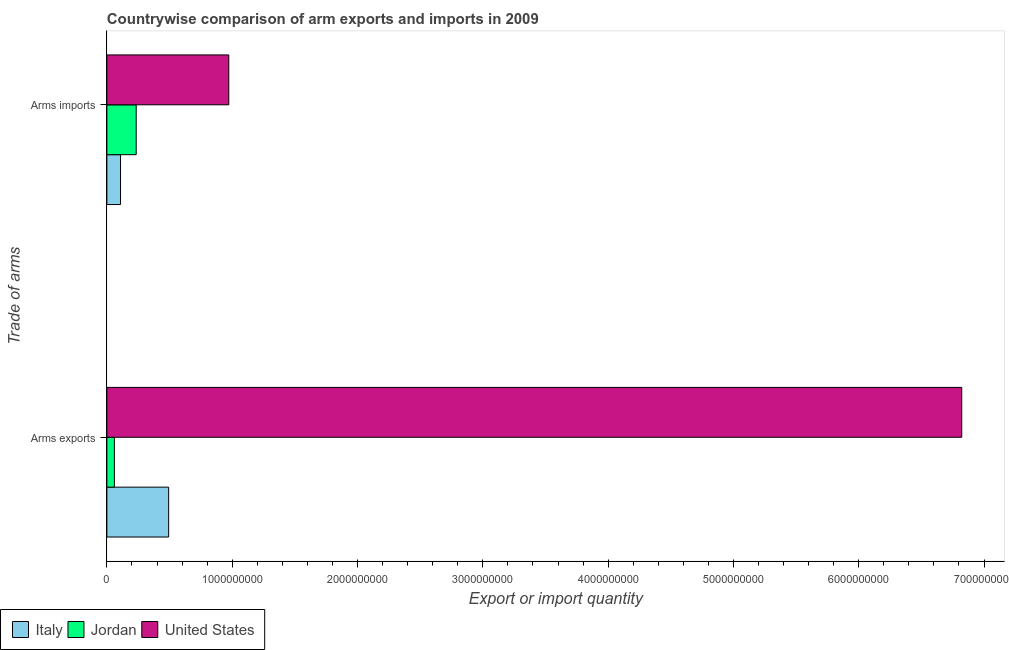How many different coloured bars are there?
Make the answer very short. 3. How many groups of bars are there?
Provide a short and direct response. 2. How many bars are there on the 2nd tick from the top?
Keep it short and to the point. 3. What is the label of the 1st group of bars from the top?
Offer a very short reply. Arms imports. What is the arms imports in Italy?
Offer a terse response. 1.09e+08. Across all countries, what is the maximum arms exports?
Keep it short and to the point. 6.82e+09. Across all countries, what is the minimum arms imports?
Provide a succinct answer. 1.09e+08. In which country was the arms exports maximum?
Keep it short and to the point. United States. In which country was the arms imports minimum?
Make the answer very short. Italy. What is the total arms imports in the graph?
Make the answer very short. 1.32e+09. What is the difference between the arms imports in Jordan and that in Italy?
Your answer should be very brief. 1.25e+08. What is the difference between the arms exports in United States and the arms imports in Jordan?
Your answer should be very brief. 6.59e+09. What is the average arms imports per country?
Offer a terse response. 4.39e+08. What is the difference between the arms imports and arms exports in Italy?
Your answer should be compact. -3.84e+08. What is the ratio of the arms exports in Italy to that in Jordan?
Provide a succinct answer. 8.22. Is the arms exports in United States less than that in Italy?
Keep it short and to the point. No. What does the 2nd bar from the top in Arms exports represents?
Ensure brevity in your answer.  Jordan. What does the 1st bar from the bottom in Arms exports represents?
Offer a terse response. Italy. How many bars are there?
Give a very brief answer. 6. Are all the bars in the graph horizontal?
Make the answer very short. Yes. What is the difference between two consecutive major ticks on the X-axis?
Provide a succinct answer. 1.00e+09. Does the graph contain any zero values?
Your answer should be very brief. No. Does the graph contain grids?
Your answer should be compact. No. What is the title of the graph?
Your response must be concise. Countrywise comparison of arm exports and imports in 2009. Does "Tanzania" appear as one of the legend labels in the graph?
Provide a short and direct response. No. What is the label or title of the X-axis?
Ensure brevity in your answer.  Export or import quantity. What is the label or title of the Y-axis?
Give a very brief answer. Trade of arms. What is the Export or import quantity of Italy in Arms exports?
Your answer should be compact. 4.93e+08. What is the Export or import quantity of Jordan in Arms exports?
Provide a succinct answer. 6.00e+07. What is the Export or import quantity in United States in Arms exports?
Provide a short and direct response. 6.82e+09. What is the Export or import quantity in Italy in Arms imports?
Offer a very short reply. 1.09e+08. What is the Export or import quantity of Jordan in Arms imports?
Ensure brevity in your answer.  2.34e+08. What is the Export or import quantity of United States in Arms imports?
Make the answer very short. 9.73e+08. Across all Trade of arms, what is the maximum Export or import quantity of Italy?
Your answer should be very brief. 4.93e+08. Across all Trade of arms, what is the maximum Export or import quantity of Jordan?
Provide a short and direct response. 2.34e+08. Across all Trade of arms, what is the maximum Export or import quantity of United States?
Your response must be concise. 6.82e+09. Across all Trade of arms, what is the minimum Export or import quantity of Italy?
Provide a short and direct response. 1.09e+08. Across all Trade of arms, what is the minimum Export or import quantity in Jordan?
Your answer should be compact. 6.00e+07. Across all Trade of arms, what is the minimum Export or import quantity in United States?
Offer a terse response. 9.73e+08. What is the total Export or import quantity in Italy in the graph?
Offer a very short reply. 6.02e+08. What is the total Export or import quantity in Jordan in the graph?
Provide a succinct answer. 2.94e+08. What is the total Export or import quantity in United States in the graph?
Keep it short and to the point. 7.80e+09. What is the difference between the Export or import quantity in Italy in Arms exports and that in Arms imports?
Ensure brevity in your answer.  3.84e+08. What is the difference between the Export or import quantity in Jordan in Arms exports and that in Arms imports?
Provide a succinct answer. -1.74e+08. What is the difference between the Export or import quantity of United States in Arms exports and that in Arms imports?
Offer a very short reply. 5.85e+09. What is the difference between the Export or import quantity of Italy in Arms exports and the Export or import quantity of Jordan in Arms imports?
Ensure brevity in your answer.  2.59e+08. What is the difference between the Export or import quantity in Italy in Arms exports and the Export or import quantity in United States in Arms imports?
Ensure brevity in your answer.  -4.80e+08. What is the difference between the Export or import quantity of Jordan in Arms exports and the Export or import quantity of United States in Arms imports?
Make the answer very short. -9.13e+08. What is the average Export or import quantity in Italy per Trade of arms?
Ensure brevity in your answer.  3.01e+08. What is the average Export or import quantity of Jordan per Trade of arms?
Provide a short and direct response. 1.47e+08. What is the average Export or import quantity of United States per Trade of arms?
Offer a terse response. 3.90e+09. What is the difference between the Export or import quantity in Italy and Export or import quantity in Jordan in Arms exports?
Give a very brief answer. 4.33e+08. What is the difference between the Export or import quantity of Italy and Export or import quantity of United States in Arms exports?
Your answer should be very brief. -6.33e+09. What is the difference between the Export or import quantity of Jordan and Export or import quantity of United States in Arms exports?
Keep it short and to the point. -6.76e+09. What is the difference between the Export or import quantity of Italy and Export or import quantity of Jordan in Arms imports?
Keep it short and to the point. -1.25e+08. What is the difference between the Export or import quantity of Italy and Export or import quantity of United States in Arms imports?
Ensure brevity in your answer.  -8.64e+08. What is the difference between the Export or import quantity of Jordan and Export or import quantity of United States in Arms imports?
Offer a very short reply. -7.39e+08. What is the ratio of the Export or import quantity of Italy in Arms exports to that in Arms imports?
Offer a very short reply. 4.52. What is the ratio of the Export or import quantity in Jordan in Arms exports to that in Arms imports?
Make the answer very short. 0.26. What is the ratio of the Export or import quantity in United States in Arms exports to that in Arms imports?
Give a very brief answer. 7.01. What is the difference between the highest and the second highest Export or import quantity of Italy?
Offer a terse response. 3.84e+08. What is the difference between the highest and the second highest Export or import quantity in Jordan?
Keep it short and to the point. 1.74e+08. What is the difference between the highest and the second highest Export or import quantity of United States?
Offer a very short reply. 5.85e+09. What is the difference between the highest and the lowest Export or import quantity of Italy?
Offer a very short reply. 3.84e+08. What is the difference between the highest and the lowest Export or import quantity in Jordan?
Keep it short and to the point. 1.74e+08. What is the difference between the highest and the lowest Export or import quantity in United States?
Provide a short and direct response. 5.85e+09. 